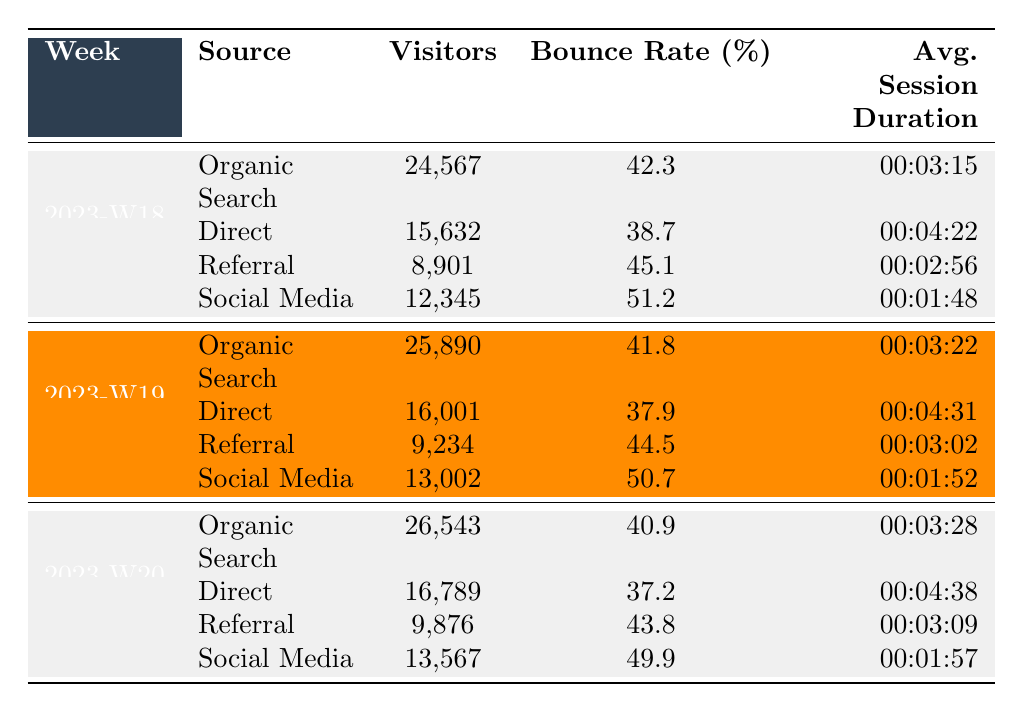What were the total visitors from Organic Search in week 2023-W20? In week 2023-W20, the table shows that Organic Search had 26,543 visitors.
Answer: 26,543 What is the Bounce Rate for Direct visitors in week 2023-W19? The table indicates that the Bounce Rate for Direct visitors in week 2023-W19 is 37.9%.
Answer: 37.9% How many more visitors did Organic Search receive in week 2023-W20 compared to week 2023-W18? Organic Search had 26,543 visitors in week 2023-W20 and 24,567 in week 2023-W18. The difference is 26,543 - 24,567 = 1,976.
Answer: 1,976 What is the average Bounce Rate for Social Media across the three weeks listed? For Social Media: Week 2023-W18 had 51.2%, Week 2023-W19 had 50.7%, and Week 2023-W20 had 49.9%. The average is (51.2 + 50.7 + 49.9) / 3 = 50.6%.
Answer: 50.6% Which source had the highest number of visitors in week 2023-W19? The table reveals that Organic Search had the most visitors in week 2023-W19 with 25,890, more than any other source listed.
Answer: Organic Search Did the average session duration for Direct visitors improve from week 2023-W18 to week 2023-W20? The Avg. Session Duration for Direct visitors in week 2023-W18 is 00:04:22 and in week 2023-W20 it is 00:04:38. Longer duration in week 2023-W20 indicates improvement.
Answer: Yes What was the total number of visitors from Referral across all three weeks? Adding the visitors from Referral: 8,901 (W18) + 9,234 (W19) + 9,876 (W20) gives a total of 27,011 visitors.
Answer: 27,011 Was the Bounce Rate for Social Media higher than 50% in all three weeks? The Bounce Rates for Social Media are 51.2% (W18), 50.7% (W19), and 49.9% (W20). The Bounce Rate dropped below 50% in week 2023-W20, so it was not higher than 50% in all weeks.
Answer: No In which week did Direct sources have the least Bounce Rate? Analyzing the data: Week 2023-W18 had a Bounce Rate of 38.7%, Week 2023-W19 had 37.9%, and Week 2023-W20 had 37.2%. The least Bounce Rate was in week 2023-W20.
Answer: Week 2023-W20 What is the percentage increase in visitors from Direct sources from week 2023-W18 to week 2023-W19? Direct sources had 15,632 visitors in week 2023-W18 and 16,001 in week 2023-W19. The increase is (16,001 - 15,632) / 15,632 * 100 = 2.35%.
Answer: 2.35% How does the average session duration for Organic Search in week 2023-W19 compare to that in week 2023-W20? Organic Search had an average session duration of 00:03:22 in week 2023-W19 and 00:03:28 in week 2023-W20. The average session duration improved from week 2023-W19 to week 2023-W20.
Answer: Yes 